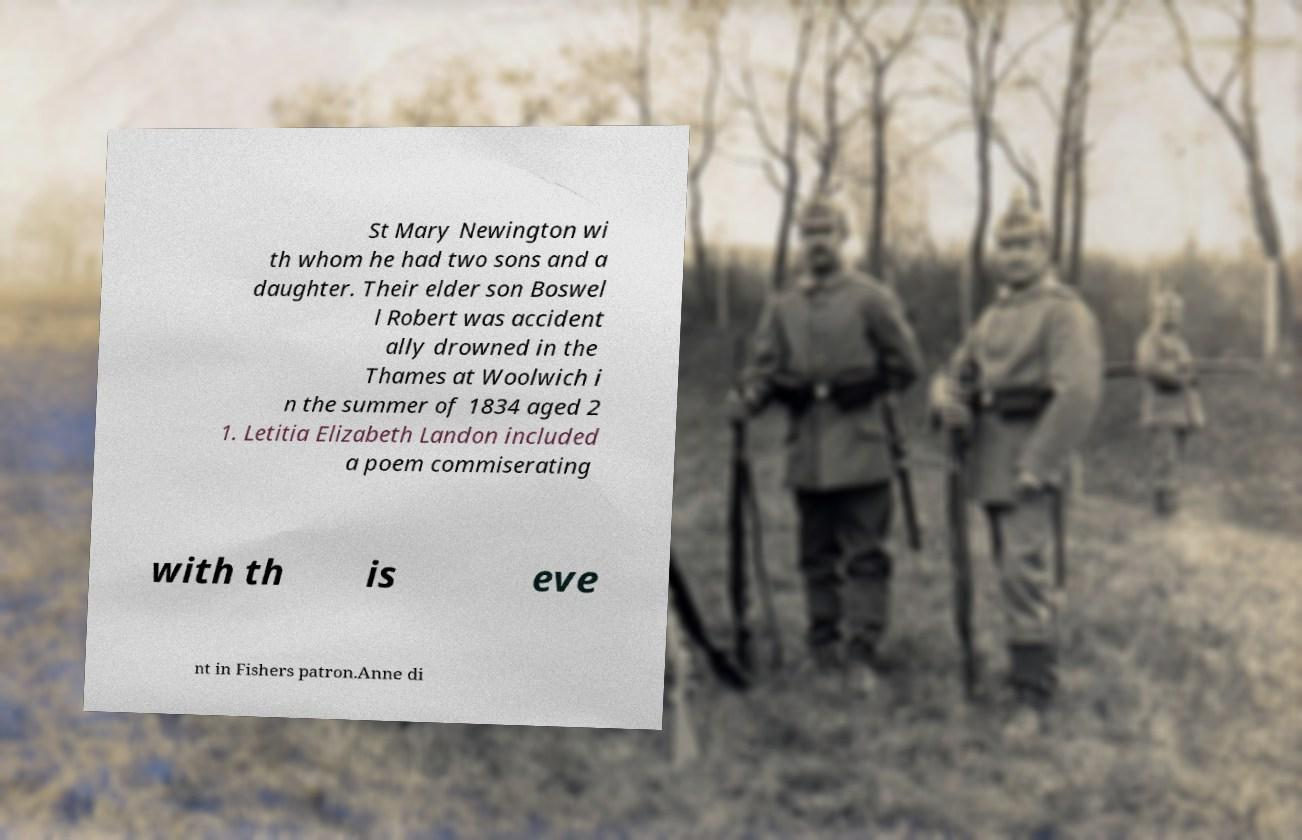Can you accurately transcribe the text from the provided image for me? St Mary Newington wi th whom he had two sons and a daughter. Their elder son Boswel l Robert was accident ally drowned in the Thames at Woolwich i n the summer of 1834 aged 2 1. Letitia Elizabeth Landon included a poem commiserating with th is eve nt in Fishers patron.Anne di 